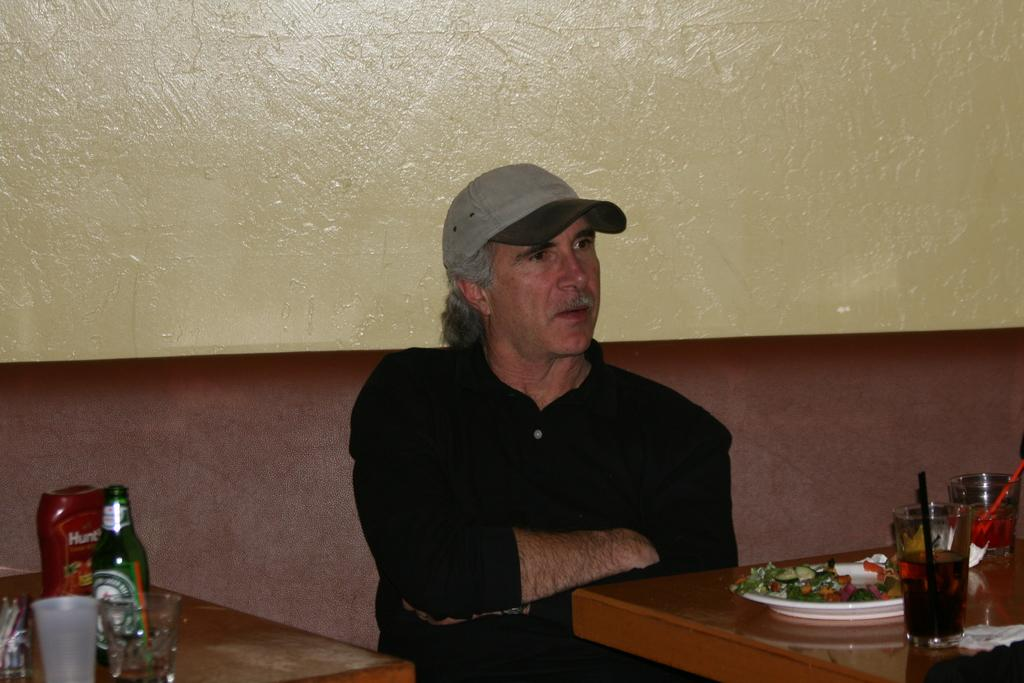<image>
Present a compact description of the photo's key features. A bottle of Hunts ketchup sits on a table next to a man in a hat. 